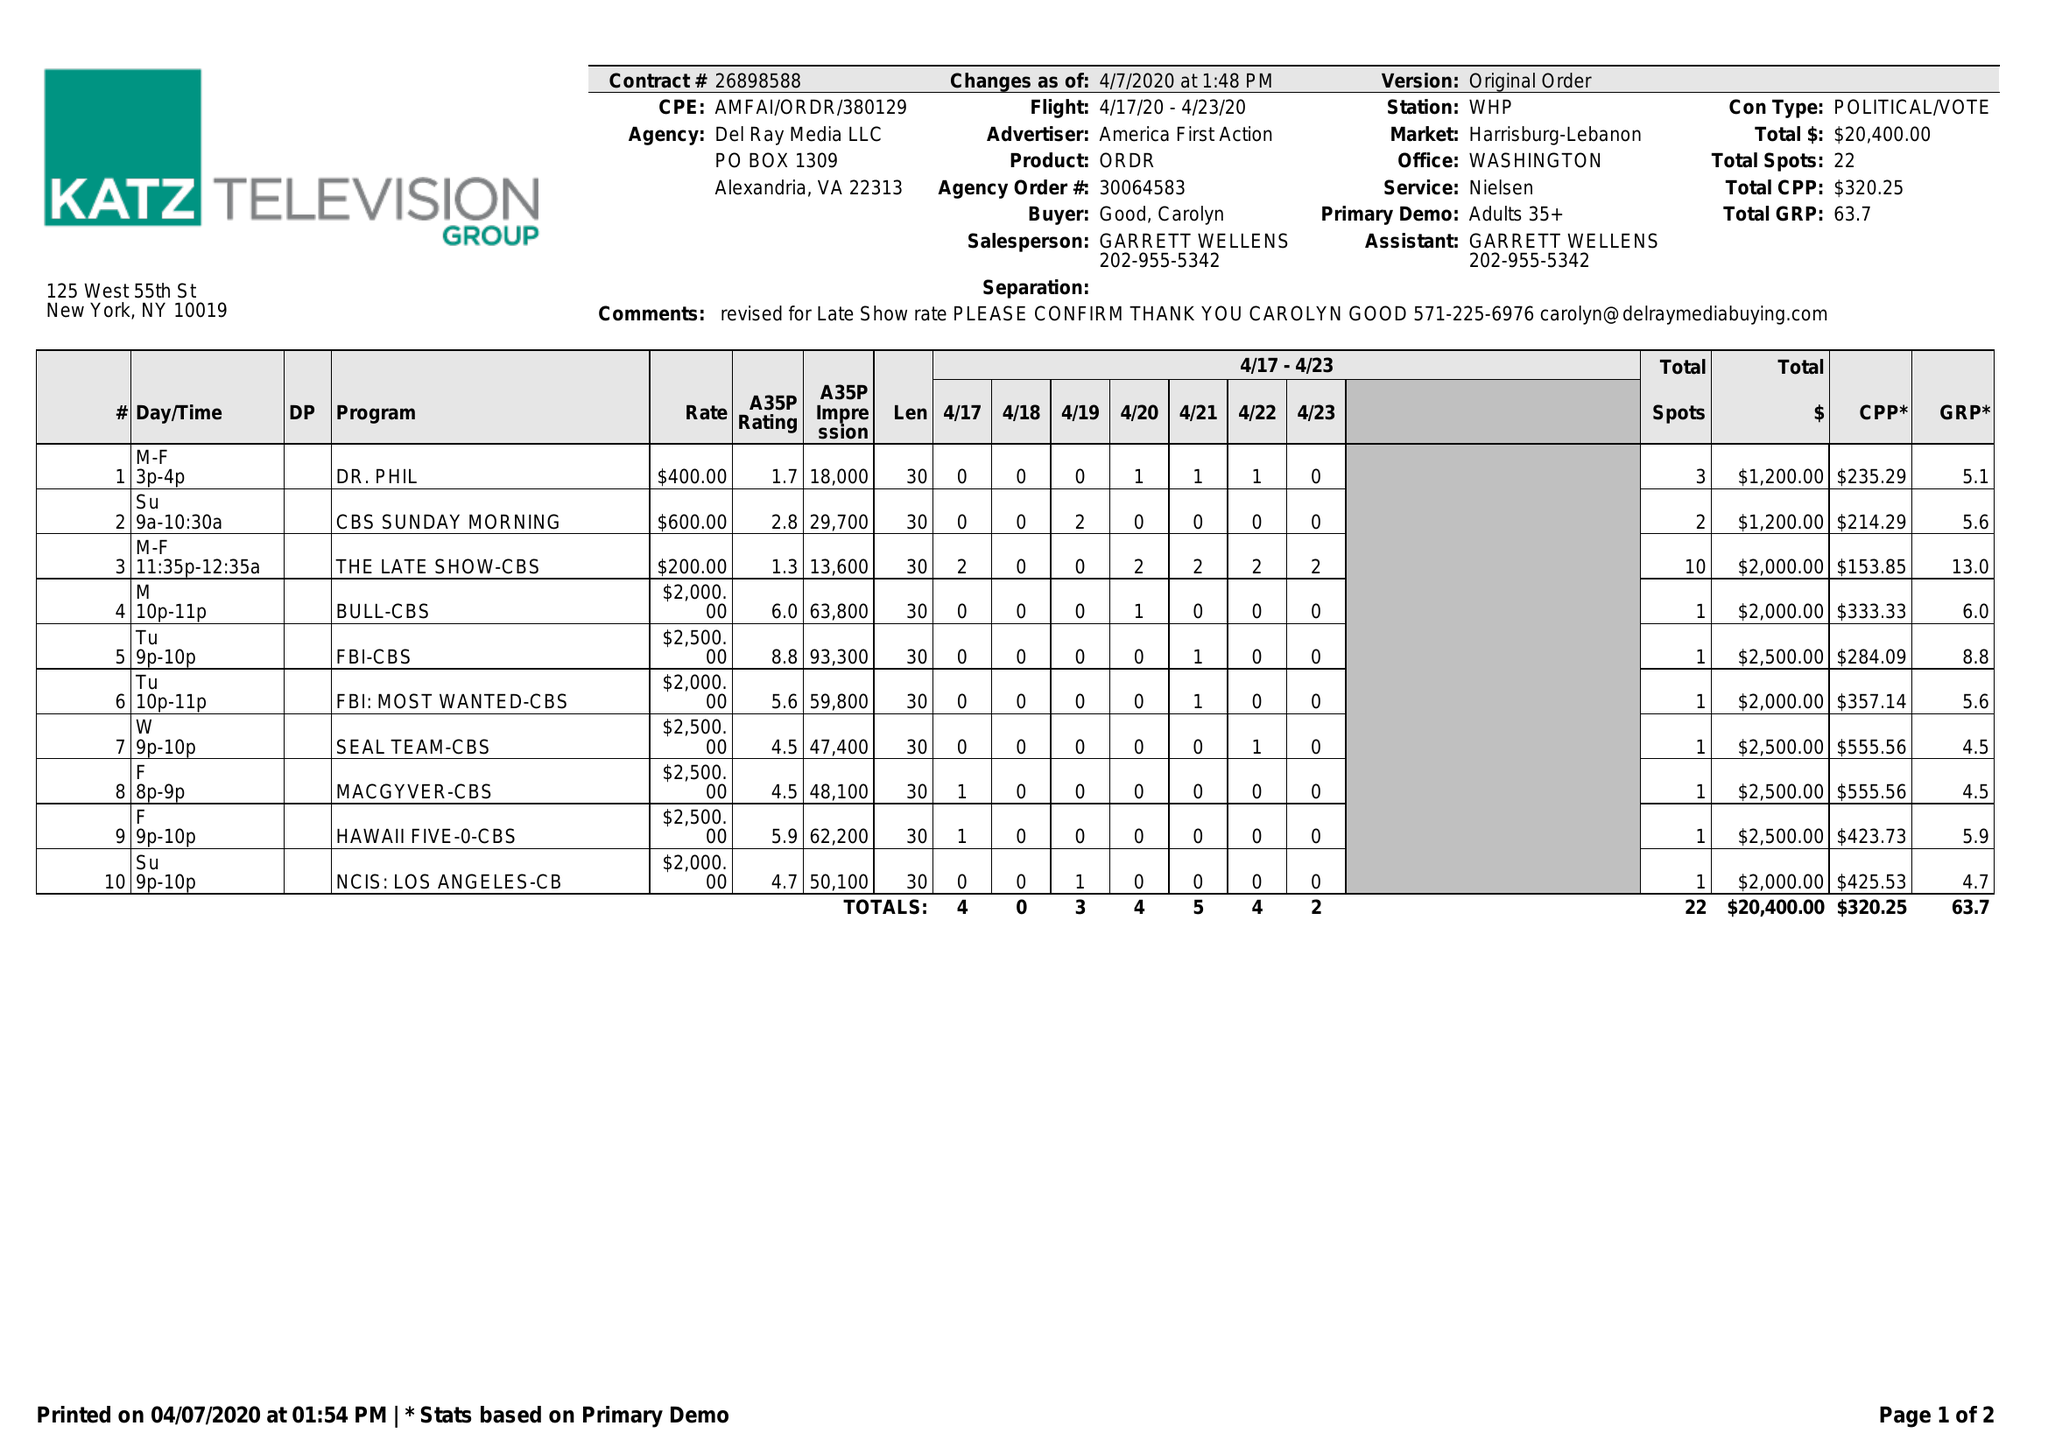What is the value for the contract_num?
Answer the question using a single word or phrase. 26898588 